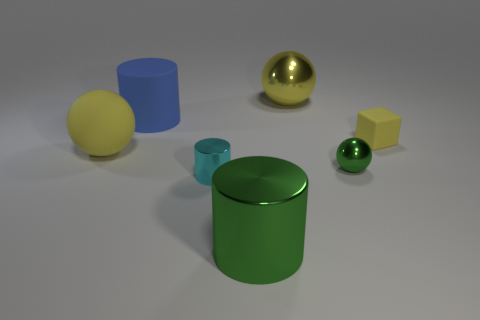There is a large yellow metallic thing; are there any tiny matte objects on the left side of it?
Your answer should be very brief. No. Is the shape of the large blue thing the same as the tiny object on the left side of the green cylinder?
Keep it short and to the point. Yes. What number of other objects are there of the same material as the blue object?
Offer a terse response. 2. There is a metal thing behind the blue object that is behind the yellow rubber thing left of the green metallic cylinder; what is its color?
Provide a succinct answer. Yellow. The large metallic object that is in front of the tiny cyan thing on the left side of the large metallic cylinder is what shape?
Your answer should be compact. Cylinder. Is the number of matte objects to the right of the tiny metallic sphere greater than the number of gray shiny balls?
Make the answer very short. Yes. There is a cyan metal thing that is in front of the rubber block; does it have the same shape as the big blue object?
Offer a very short reply. Yes. Are there any brown metal objects of the same shape as the small cyan shiny object?
Your answer should be very brief. No. What number of things are either matte objects that are right of the green cylinder or tiny gray metal objects?
Your answer should be compact. 1. Is the number of small matte blocks greater than the number of big yellow metallic blocks?
Give a very brief answer. Yes. 